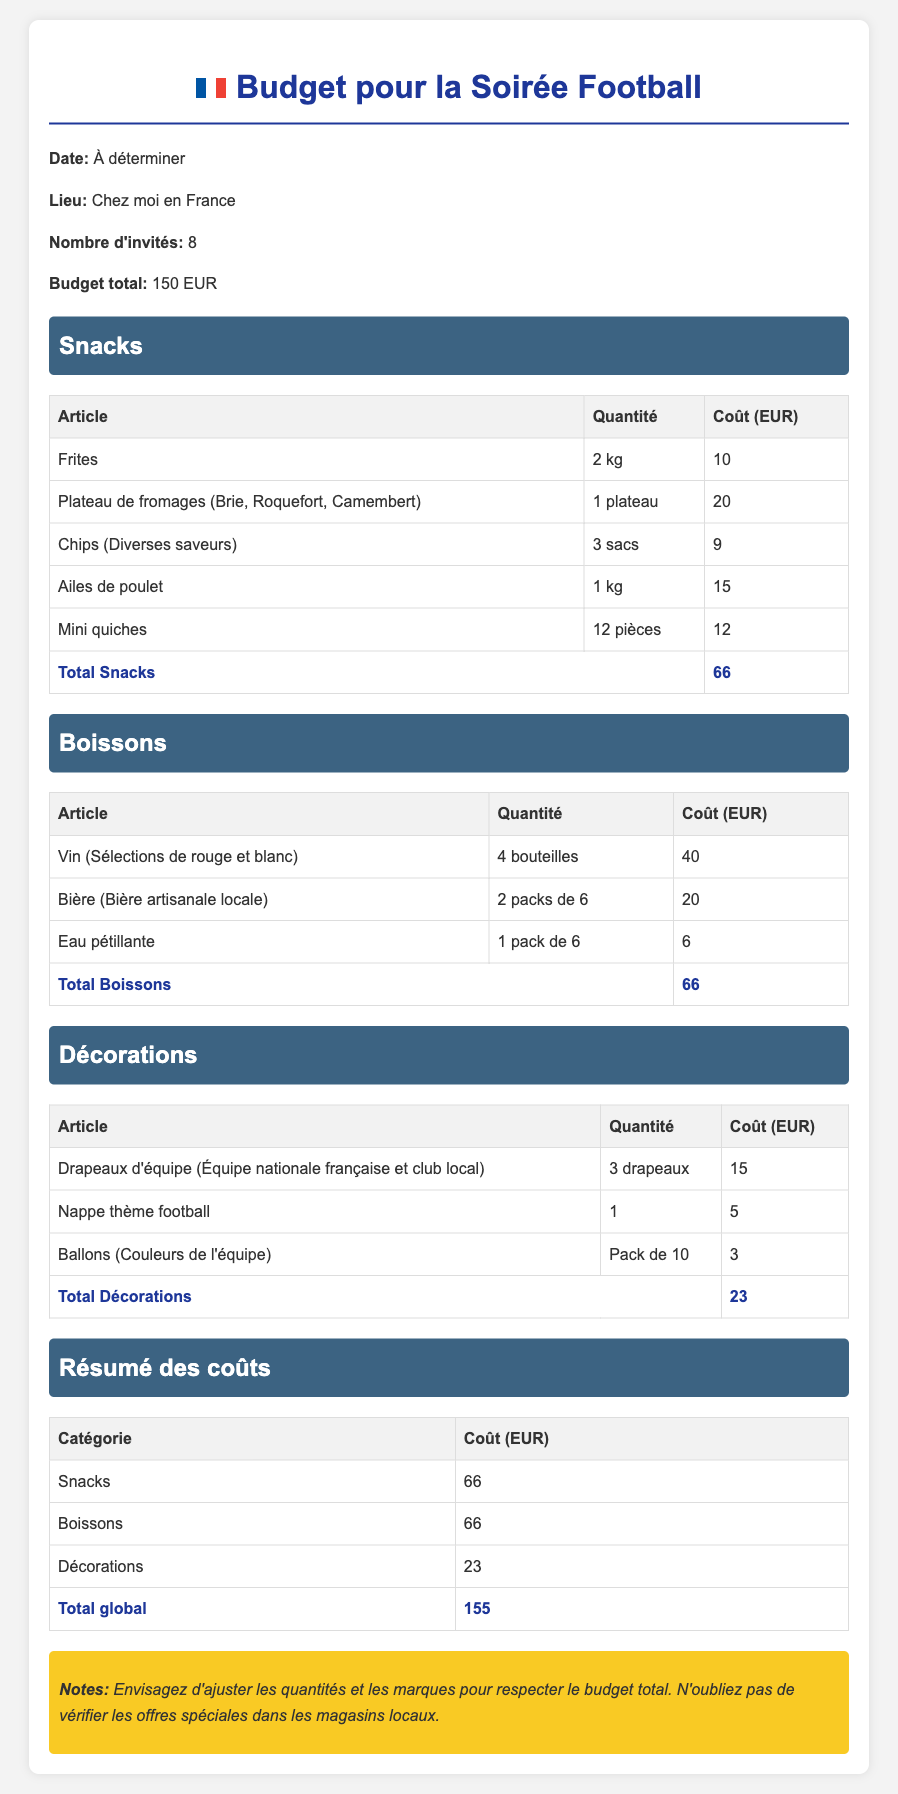Quel est le budget total ? Le budget total est mentionné dans la section des informations générales, qui indique un montant de 150 EUR.
Answer: 150 EUR Combien d'invités sont attendus ? Le nombre d'invités est indiqué dans la section des informations générales, précisant qu'il y aura 8 personnes.
Answer: 8 Quel est le coût des boissons ? Le coût des boissons est le total calculé dans la section correspondante, qui indique 66 EUR.
Answer: 66 EUR Combien de bouteilles de vin sont prévues ? La quantité de bouteilles de vin est spécifiée dans la section Boissons, indiquant qu'il y aura 4 bouteilles.
Answer: 4 bouteilles Quel est le coût total des décorations ? Le total des décorations est mentionné dans la section des décorations, qui s'élève à 23 EUR.
Answer: 23 EUR Quelle est la quantité de chips prévue ? La quantité de chips est précisée dans la section Snacks, indiquant 3 sacs.
Answer: 3 sacs Quel est le coût total global ? Le coût total global est le résultat de l'addition des coûts des snacks, boissons et décorations, qui est de 155 EUR.
Answer: 155 EUR Combien de drapeaux d'équipe sont inclus dans le budget ? La section Décorations indique qu'il y a 3 drapeaux d'équipe dans le budget.
Answer: 3 Quelles types de fromages sont dans le plateau ? La section Snacks mentionne Brie, Roquefort, et Camembert pour le plateau de fromages.
Answer: Brie, Roquefort, Camembert 